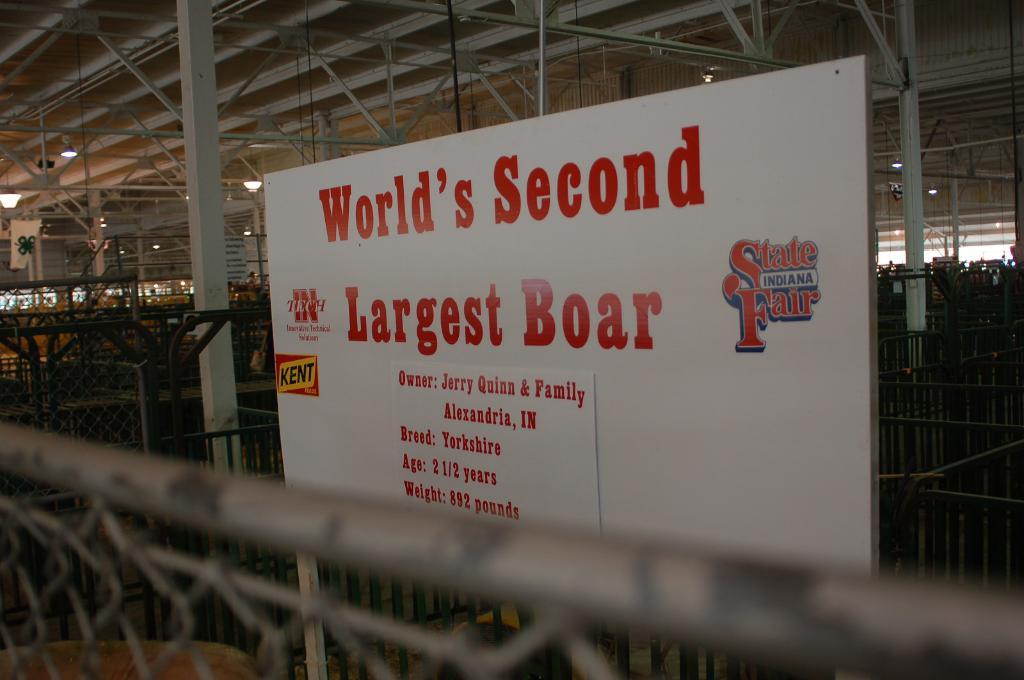What state is this fair located  in?
Your answer should be very brief. Indiana. Is this sign advertising the world's largest boar?
Make the answer very short. Yes. 